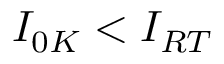Convert formula to latex. <formula><loc_0><loc_0><loc_500><loc_500>I _ { 0 K } < I _ { R T }</formula> 